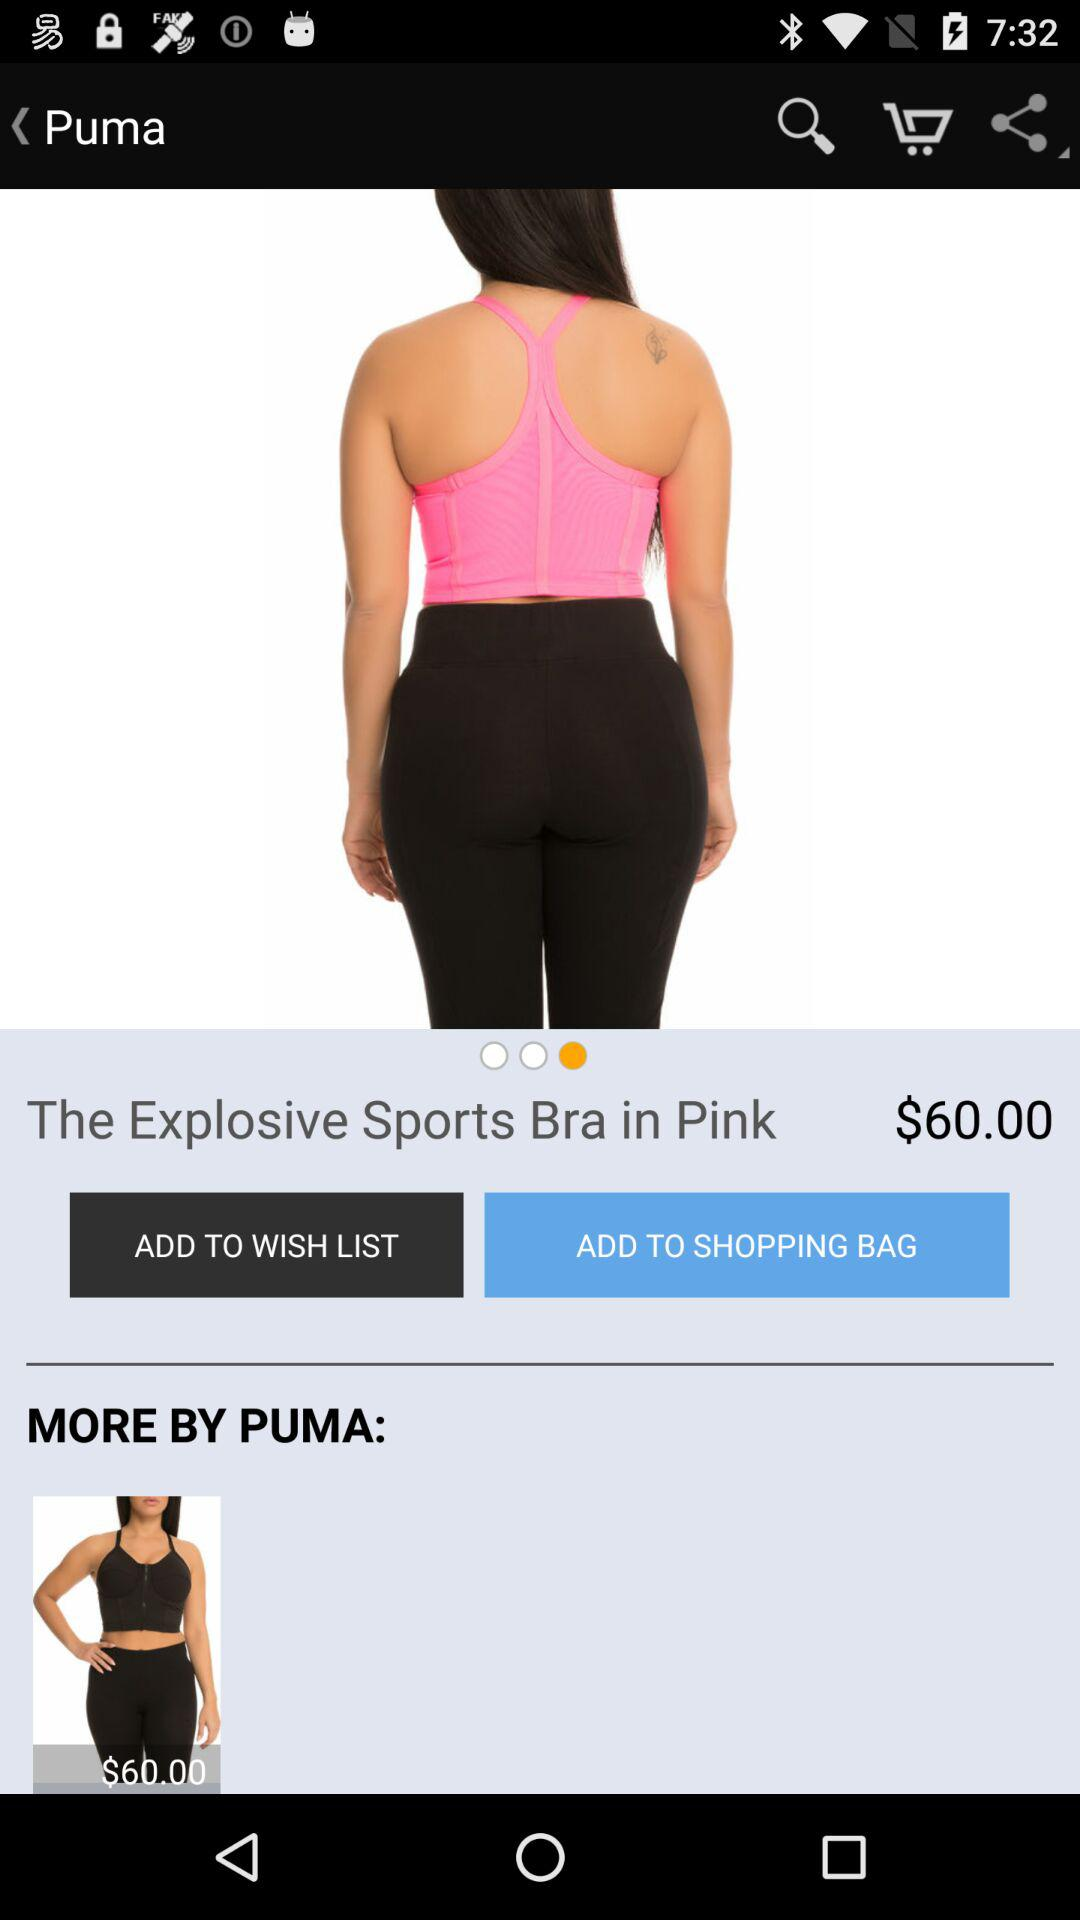What is the name of the product?
Answer the question using a single word or phrase. The name of the product is "The Explosive Sports Bra" 